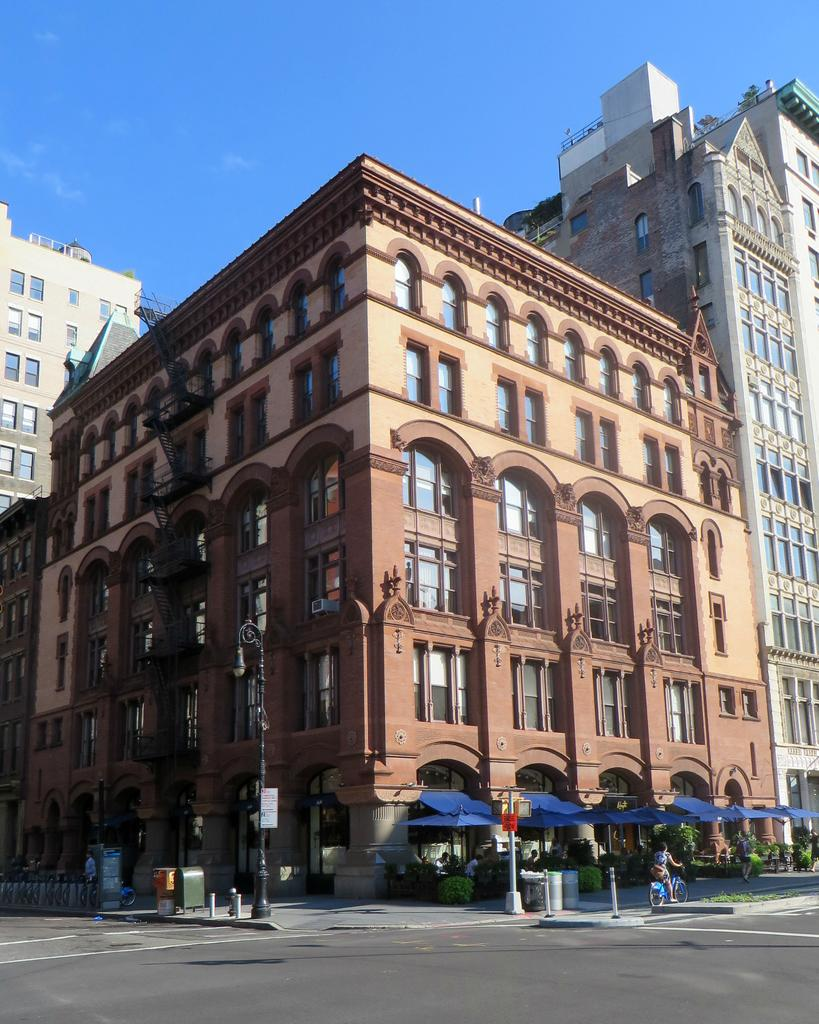What is the main feature of the image? There is a road in the image. What can be seen in the distance behind the road? There is a building in the background of the image. What is located in front of the building? There is a footpath in front of the building. What activities are taking place on the footpath? A person is riding a bicycle, and a man is walking on the footpath. What type of books can be found in the library depicted in the image? There is no library present in the image; it features a road, a building, a footpath, and people engaging in activities. 